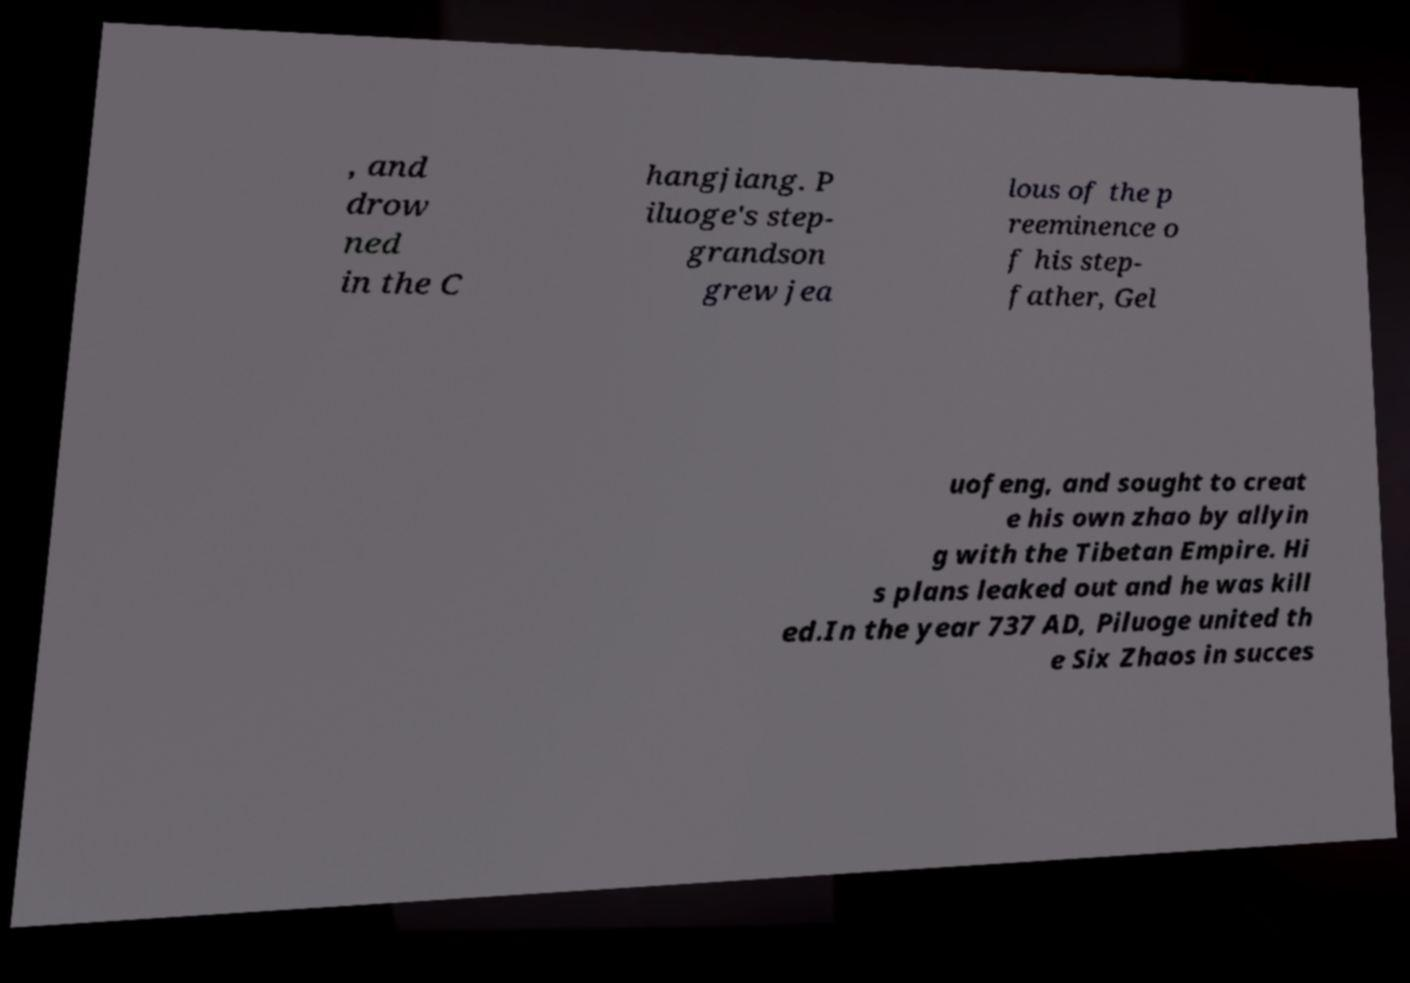Could you extract and type out the text from this image? , and drow ned in the C hangjiang. P iluoge's step- grandson grew jea lous of the p reeminence o f his step- father, Gel uofeng, and sought to creat e his own zhao by allyin g with the Tibetan Empire. Hi s plans leaked out and he was kill ed.In the year 737 AD, Piluoge united th e Six Zhaos in succes 